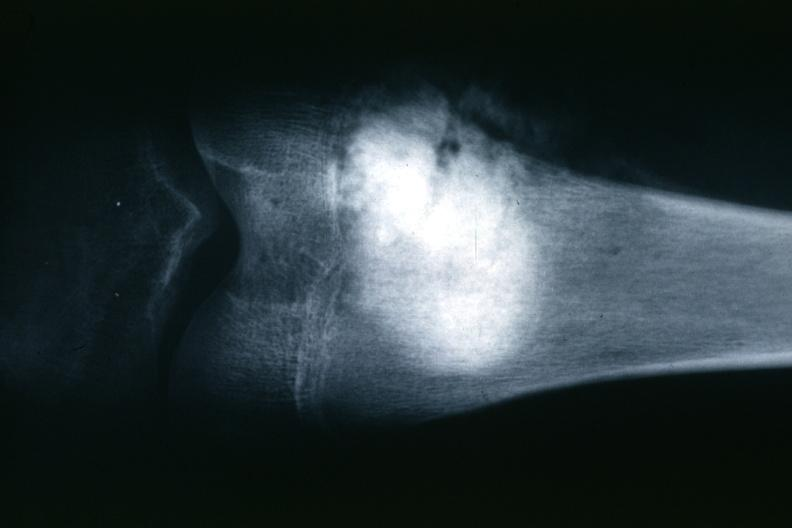what is present?
Answer the question using a single word or phrase. Joints 